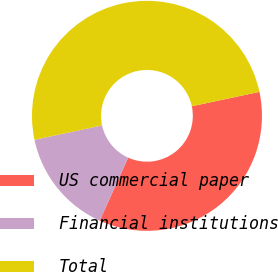Convert chart. <chart><loc_0><loc_0><loc_500><loc_500><pie_chart><fcel>US commercial paper<fcel>Financial institutions<fcel>Total<nl><fcel>35.08%<fcel>14.92%<fcel>50.0%<nl></chart> 